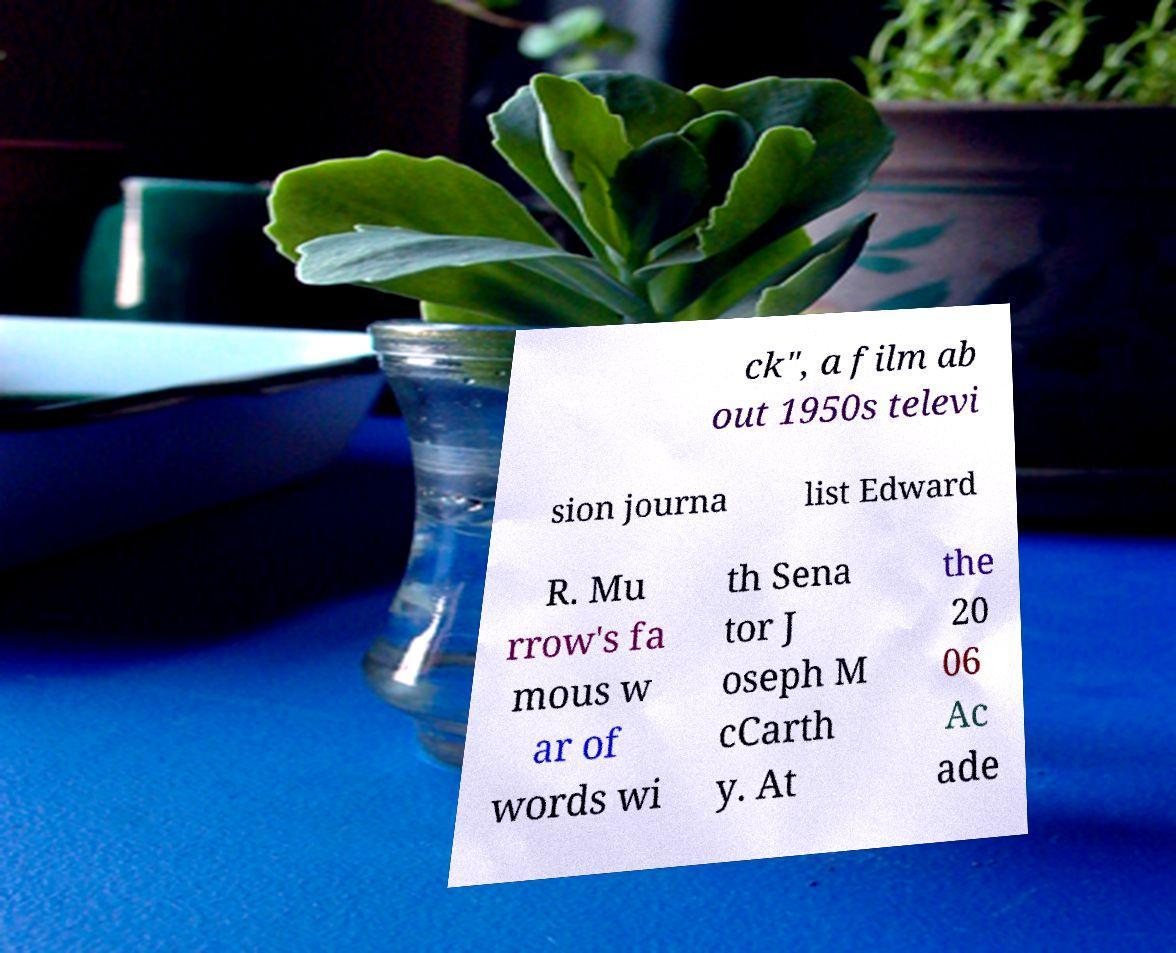Could you extract and type out the text from this image? ck", a film ab out 1950s televi sion journa list Edward R. Mu rrow's fa mous w ar of words wi th Sena tor J oseph M cCarth y. At the 20 06 Ac ade 